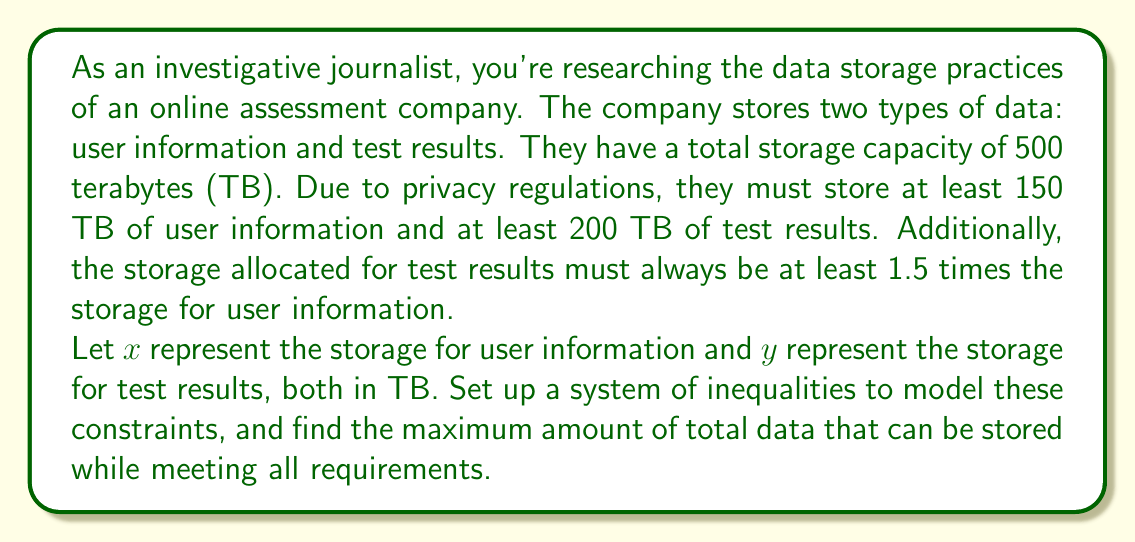Provide a solution to this math problem. Let's approach this step-by-step:

1) First, we need to set up our system of inequalities based on the given constraints:

   a) Total storage: $x + y \leq 500$
   b) Minimum user information: $x \geq 150$
   c) Minimum test results: $y \geq 200$
   d) Test results at least 1.5 times user information: $y \geq 1.5x$

2) Our system of inequalities is:

   $$\begin{cases}
   x + y \leq 500 \\
   x \geq 150 \\
   y \geq 200 \\
   y \geq 1.5x
   \end{cases}$$

3) To maximize the total data stored, we need to maximize $x + y$.

4) The optimal solution will be at one of the intersection points of these inequalities. Let's find these points:

   a) Intersection of $x + y = 500$ and $y = 1.5x$:
      $500 = x + 1.5x = 2.5x$
      $x = 200$, $y = 300$

   b) Intersection of $x + y = 500$ and $x = 150$:
      $y = 500 - 150 = 350$

   c) Intersection of $x + y = 500$ and $y = 200$:
      $x = 500 - 200 = 300$

5) Point (200, 300) satisfies all inequalities and gives the maximum sum of $x + y = 500$.

Therefore, the maximum amount of total data that can be stored is 500 TB, with 200 TB for user information and 300 TB for test results.
Answer: The maximum amount of total data that can be stored is 500 TB, with 200 TB allocated for user information and 300 TB for test results. 